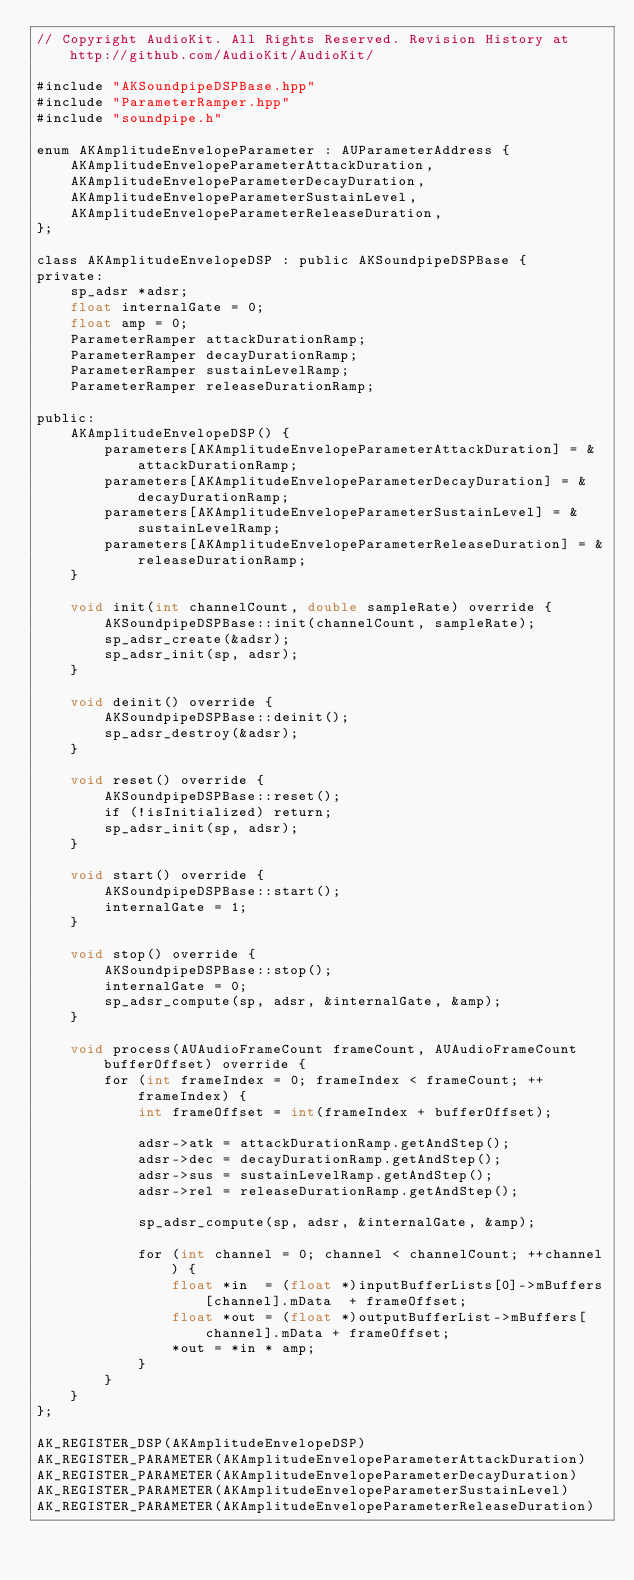Convert code to text. <code><loc_0><loc_0><loc_500><loc_500><_ObjectiveC_>// Copyright AudioKit. All Rights Reserved. Revision History at http://github.com/AudioKit/AudioKit/

#include "AKSoundpipeDSPBase.hpp"
#include "ParameterRamper.hpp"
#include "soundpipe.h"

enum AKAmplitudeEnvelopeParameter : AUParameterAddress {
    AKAmplitudeEnvelopeParameterAttackDuration,
    AKAmplitudeEnvelopeParameterDecayDuration,
    AKAmplitudeEnvelopeParameterSustainLevel,
    AKAmplitudeEnvelopeParameterReleaseDuration,
};

class AKAmplitudeEnvelopeDSP : public AKSoundpipeDSPBase {
private:
    sp_adsr *adsr;
    float internalGate = 0;
    float amp = 0;
    ParameterRamper attackDurationRamp;
    ParameterRamper decayDurationRamp;
    ParameterRamper sustainLevelRamp;
    ParameterRamper releaseDurationRamp;

public:
    AKAmplitudeEnvelopeDSP() {
        parameters[AKAmplitudeEnvelopeParameterAttackDuration] = &attackDurationRamp;
        parameters[AKAmplitudeEnvelopeParameterDecayDuration] = &decayDurationRamp;
        parameters[AKAmplitudeEnvelopeParameterSustainLevel] = &sustainLevelRamp;
        parameters[AKAmplitudeEnvelopeParameterReleaseDuration] = &releaseDurationRamp;
    }

    void init(int channelCount, double sampleRate) override {
        AKSoundpipeDSPBase::init(channelCount, sampleRate);
        sp_adsr_create(&adsr);
        sp_adsr_init(sp, adsr);
    }

    void deinit() override {
        AKSoundpipeDSPBase::deinit();
        sp_adsr_destroy(&adsr);
    }

    void reset() override {
        AKSoundpipeDSPBase::reset();
        if (!isInitialized) return;
        sp_adsr_init(sp, adsr);
    }

    void start() override {
        AKSoundpipeDSPBase::start();
        internalGate = 1;
    }

    void stop() override {
        AKSoundpipeDSPBase::stop();
        internalGate = 0;
        sp_adsr_compute(sp, adsr, &internalGate, &amp);
    }

    void process(AUAudioFrameCount frameCount, AUAudioFrameCount bufferOffset) override {
        for (int frameIndex = 0; frameIndex < frameCount; ++frameIndex) {
            int frameOffset = int(frameIndex + bufferOffset);

            adsr->atk = attackDurationRamp.getAndStep();
            adsr->dec = decayDurationRamp.getAndStep();
            adsr->sus = sustainLevelRamp.getAndStep();
            adsr->rel = releaseDurationRamp.getAndStep();

            sp_adsr_compute(sp, adsr, &internalGate, &amp);

            for (int channel = 0; channel < channelCount; ++channel) {
                float *in  = (float *)inputBufferLists[0]->mBuffers[channel].mData  + frameOffset;
                float *out = (float *)outputBufferList->mBuffers[channel].mData + frameOffset;
                *out = *in * amp;
            }
        }
    }
};

AK_REGISTER_DSP(AKAmplitudeEnvelopeDSP)
AK_REGISTER_PARAMETER(AKAmplitudeEnvelopeParameterAttackDuration)
AK_REGISTER_PARAMETER(AKAmplitudeEnvelopeParameterDecayDuration)
AK_REGISTER_PARAMETER(AKAmplitudeEnvelopeParameterSustainLevel)
AK_REGISTER_PARAMETER(AKAmplitudeEnvelopeParameterReleaseDuration)
</code> 